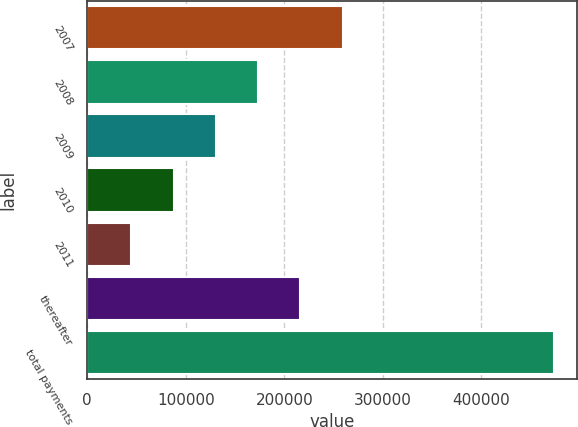Convert chart to OTSL. <chart><loc_0><loc_0><loc_500><loc_500><bar_chart><fcel>2007<fcel>2008<fcel>2009<fcel>2010<fcel>2011<fcel>thereafter<fcel>total payments<nl><fcel>259298<fcel>173517<fcel>130627<fcel>87736.4<fcel>44846<fcel>216408<fcel>473750<nl></chart> 